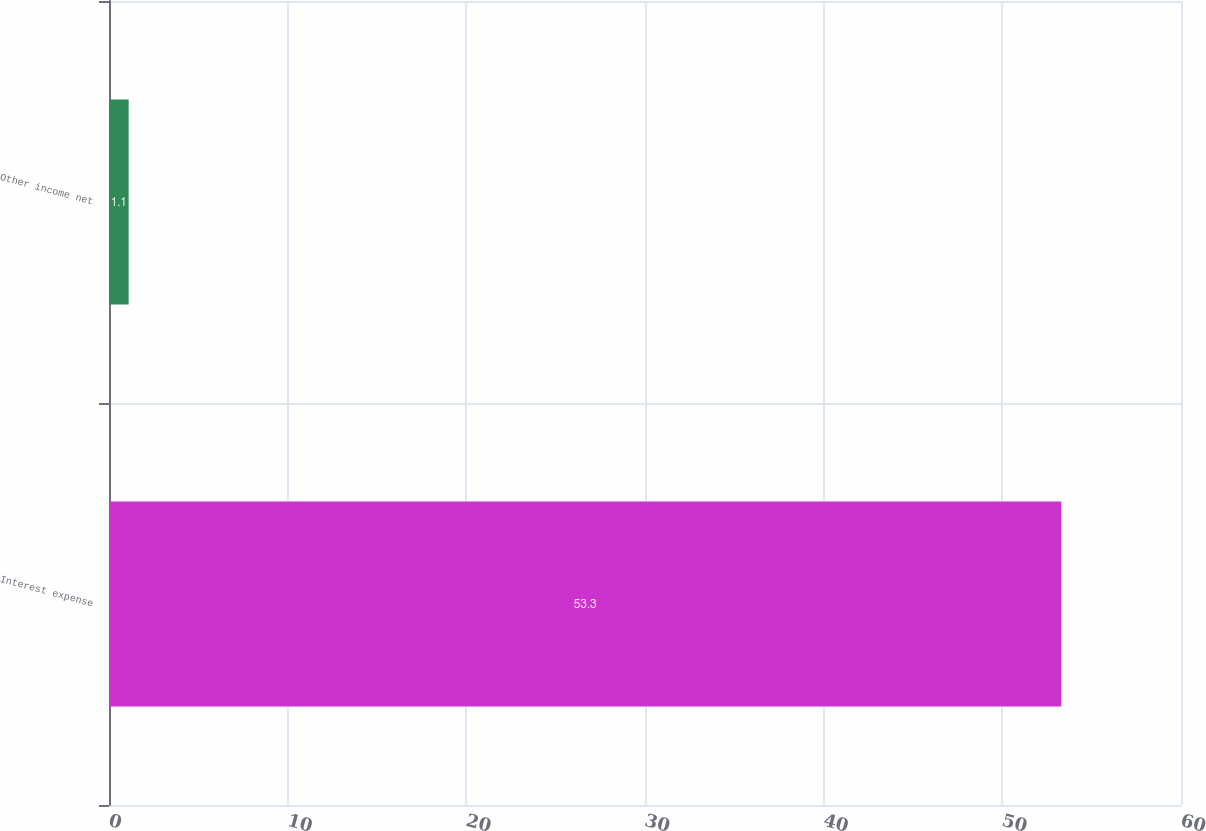Convert chart to OTSL. <chart><loc_0><loc_0><loc_500><loc_500><bar_chart><fcel>Interest expense<fcel>Other income net<nl><fcel>53.3<fcel>1.1<nl></chart> 